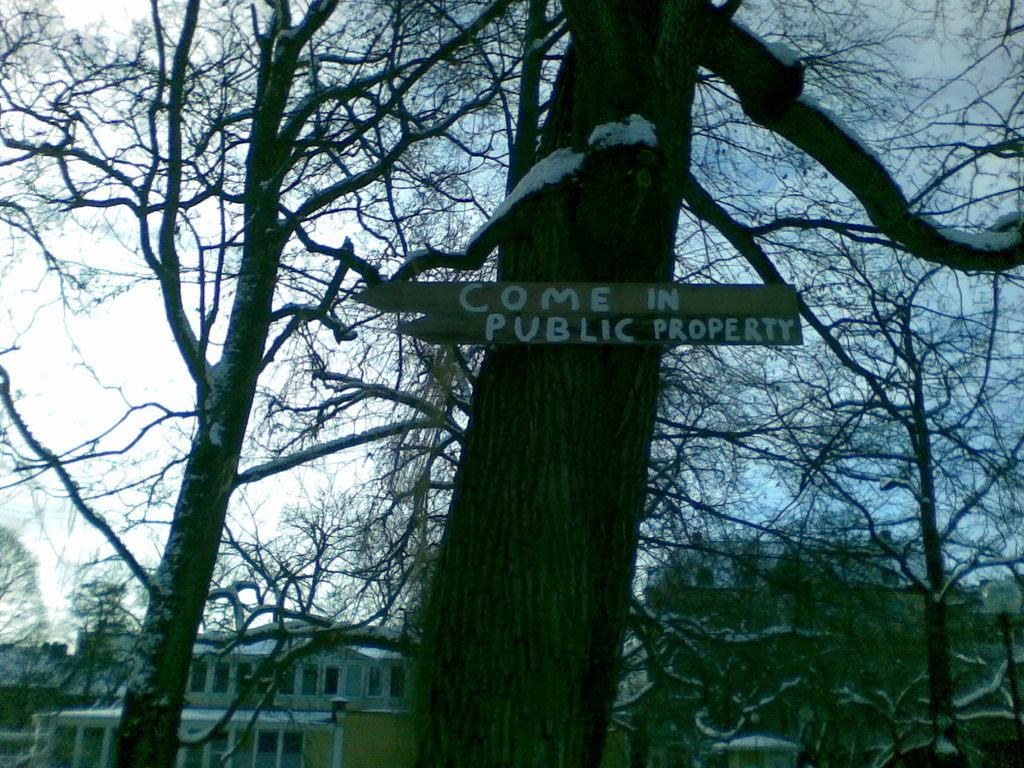What type of natural elements can be seen in the image? There are trees in the image. Is there any text or signage visible on the trees? Yes, there is a name board on one of the trees. What type of man-made structures can be seen in the image? There are buildings in the image. What part of the natural environment is visible in the image? The sky is visible in the image. What type of book is being used to destroy the buildings in the image? There is no book or destruction present in the image; it features trees, a name board, buildings, and the sky. 